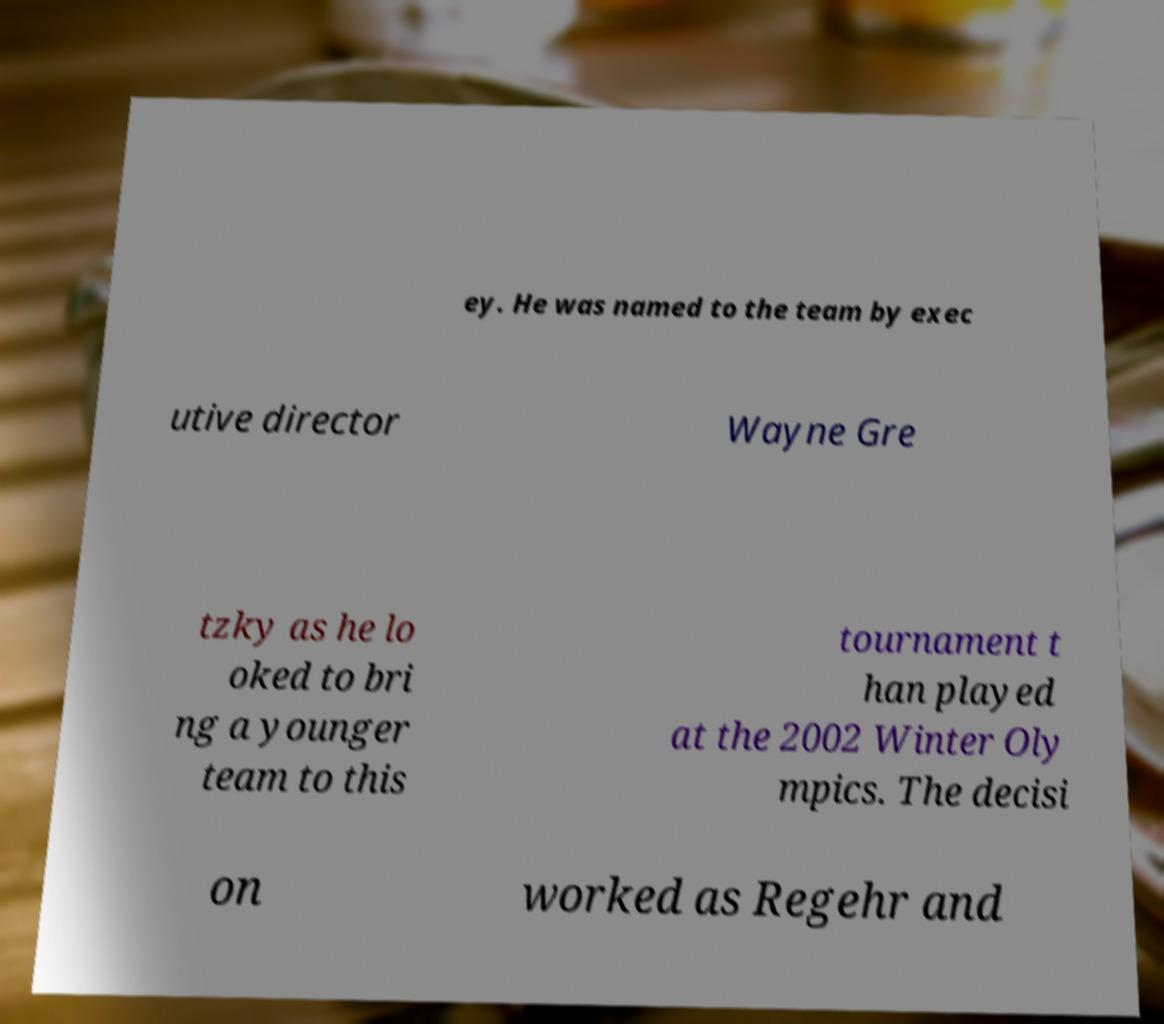I need the written content from this picture converted into text. Can you do that? ey. He was named to the team by exec utive director Wayne Gre tzky as he lo oked to bri ng a younger team to this tournament t han played at the 2002 Winter Oly mpics. The decisi on worked as Regehr and 